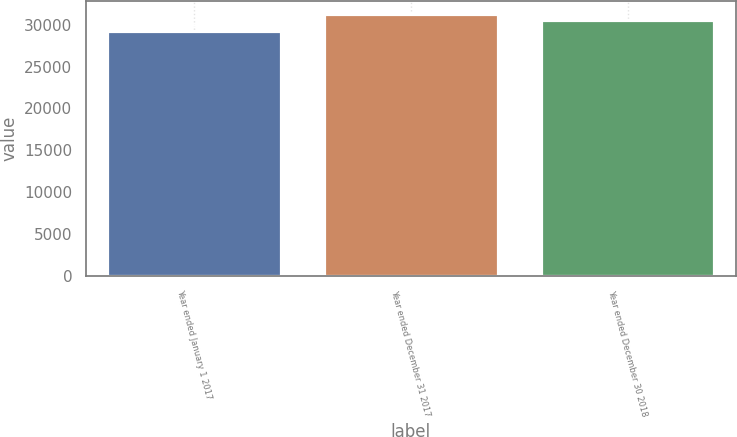Convert chart. <chart><loc_0><loc_0><loc_500><loc_500><bar_chart><fcel>Year ended January 1 2017<fcel>Year ended December 31 2017<fcel>Year ended December 30 2018<nl><fcel>29212<fcel>31281<fcel>30590<nl></chart> 